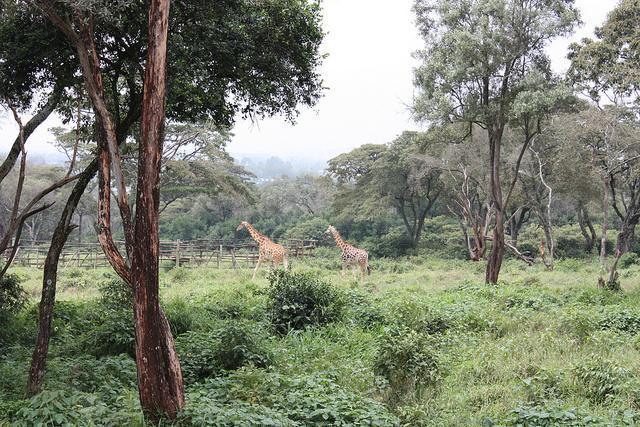How many animals are there?
Give a very brief answer. 2. How many animals can be seen?
Give a very brief answer. 2. 